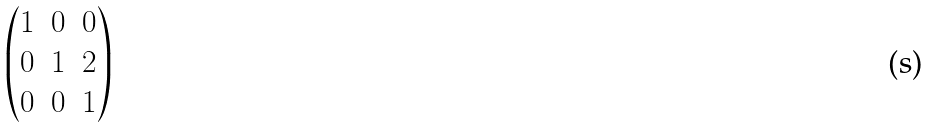<formula> <loc_0><loc_0><loc_500><loc_500>\begin{pmatrix} 1 & 0 & 0 \\ 0 & 1 & 2 \\ 0 & 0 & 1 \end{pmatrix}</formula> 